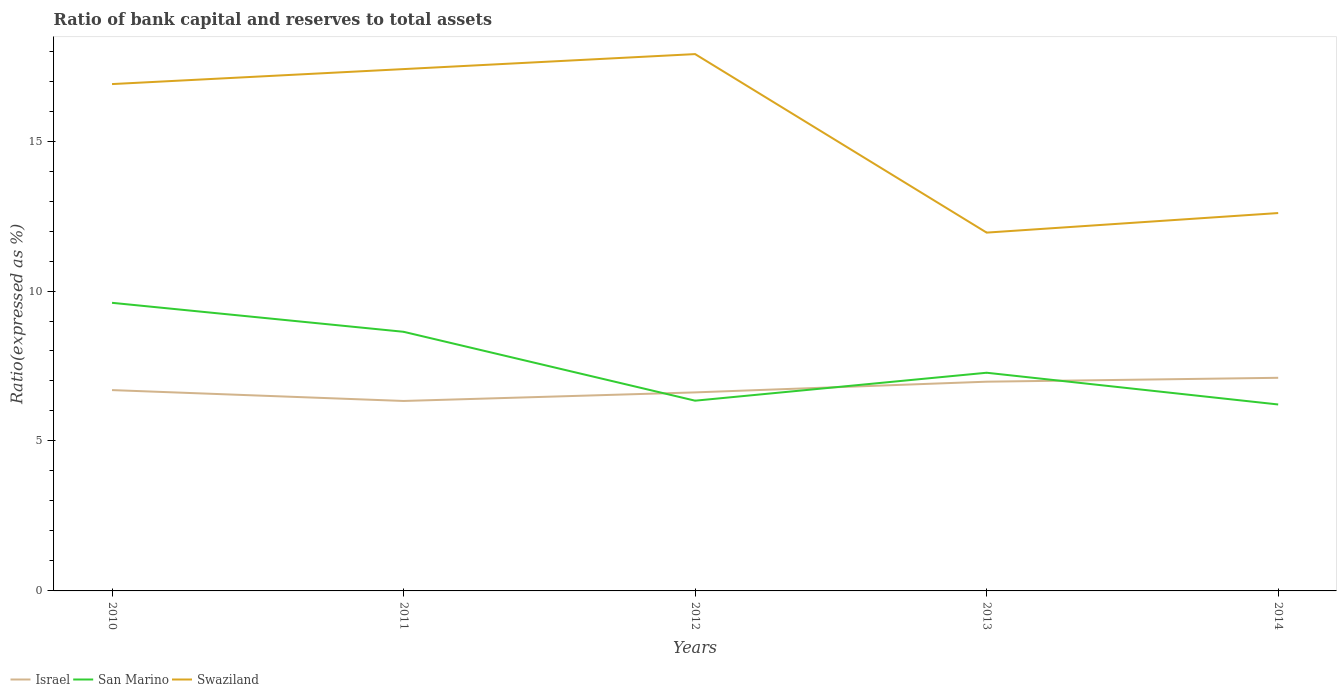How many different coloured lines are there?
Make the answer very short. 3. Does the line corresponding to Israel intersect with the line corresponding to San Marino?
Your answer should be very brief. Yes. Is the number of lines equal to the number of legend labels?
Offer a terse response. Yes. Across all years, what is the maximum ratio of bank capital and reserves to total assets in San Marino?
Make the answer very short. 6.22. In which year was the ratio of bank capital and reserves to total assets in Swaziland maximum?
Your answer should be compact. 2013. What is the total ratio of bank capital and reserves to total assets in San Marino in the graph?
Offer a very short reply. 0.13. What is the difference between the highest and the second highest ratio of bank capital and reserves to total assets in Israel?
Give a very brief answer. 0.77. How many lines are there?
Give a very brief answer. 3. How many years are there in the graph?
Your response must be concise. 5. What is the difference between two consecutive major ticks on the Y-axis?
Ensure brevity in your answer.  5. Does the graph contain any zero values?
Offer a terse response. No. How are the legend labels stacked?
Offer a terse response. Horizontal. What is the title of the graph?
Keep it short and to the point. Ratio of bank capital and reserves to total assets. Does "Channel Islands" appear as one of the legend labels in the graph?
Provide a short and direct response. No. What is the label or title of the X-axis?
Make the answer very short. Years. What is the label or title of the Y-axis?
Your answer should be compact. Ratio(expressed as %). What is the Ratio(expressed as %) in Israel in 2010?
Provide a succinct answer. 6.7. What is the Ratio(expressed as %) of San Marino in 2010?
Offer a very short reply. 9.61. What is the Ratio(expressed as %) of Israel in 2011?
Make the answer very short. 6.33. What is the Ratio(expressed as %) in San Marino in 2011?
Your answer should be very brief. 8.64. What is the Ratio(expressed as %) in Israel in 2012?
Give a very brief answer. 6.62. What is the Ratio(expressed as %) of San Marino in 2012?
Offer a very short reply. 6.34. What is the Ratio(expressed as %) in Swaziland in 2012?
Provide a succinct answer. 17.9. What is the Ratio(expressed as %) in Israel in 2013?
Provide a short and direct response. 6.98. What is the Ratio(expressed as %) in San Marino in 2013?
Give a very brief answer. 7.28. What is the Ratio(expressed as %) in Swaziland in 2013?
Ensure brevity in your answer.  11.95. What is the Ratio(expressed as %) in Israel in 2014?
Ensure brevity in your answer.  7.11. What is the Ratio(expressed as %) of San Marino in 2014?
Ensure brevity in your answer.  6.22. Across all years, what is the maximum Ratio(expressed as %) of Israel?
Your answer should be compact. 7.11. Across all years, what is the maximum Ratio(expressed as %) of San Marino?
Keep it short and to the point. 9.61. Across all years, what is the minimum Ratio(expressed as %) in Israel?
Ensure brevity in your answer.  6.33. Across all years, what is the minimum Ratio(expressed as %) in San Marino?
Your response must be concise. 6.22. Across all years, what is the minimum Ratio(expressed as %) of Swaziland?
Provide a short and direct response. 11.95. What is the total Ratio(expressed as %) of Israel in the graph?
Offer a terse response. 33.73. What is the total Ratio(expressed as %) of San Marino in the graph?
Give a very brief answer. 38.08. What is the total Ratio(expressed as %) in Swaziland in the graph?
Provide a succinct answer. 76.75. What is the difference between the Ratio(expressed as %) in Israel in 2010 and that in 2011?
Give a very brief answer. 0.36. What is the difference between the Ratio(expressed as %) of San Marino in 2010 and that in 2011?
Offer a terse response. 0.97. What is the difference between the Ratio(expressed as %) of Swaziland in 2010 and that in 2011?
Make the answer very short. -0.5. What is the difference between the Ratio(expressed as %) in Israel in 2010 and that in 2012?
Give a very brief answer. 0.08. What is the difference between the Ratio(expressed as %) of San Marino in 2010 and that in 2012?
Your response must be concise. 3.26. What is the difference between the Ratio(expressed as %) of Israel in 2010 and that in 2013?
Give a very brief answer. -0.28. What is the difference between the Ratio(expressed as %) in San Marino in 2010 and that in 2013?
Make the answer very short. 2.33. What is the difference between the Ratio(expressed as %) in Swaziland in 2010 and that in 2013?
Provide a succinct answer. 4.95. What is the difference between the Ratio(expressed as %) of Israel in 2010 and that in 2014?
Offer a very short reply. -0.41. What is the difference between the Ratio(expressed as %) of San Marino in 2010 and that in 2014?
Ensure brevity in your answer.  3.39. What is the difference between the Ratio(expressed as %) of Israel in 2011 and that in 2012?
Your answer should be compact. -0.29. What is the difference between the Ratio(expressed as %) of San Marino in 2011 and that in 2012?
Provide a short and direct response. 2.3. What is the difference between the Ratio(expressed as %) in Israel in 2011 and that in 2013?
Your answer should be very brief. -0.64. What is the difference between the Ratio(expressed as %) in San Marino in 2011 and that in 2013?
Your answer should be compact. 1.37. What is the difference between the Ratio(expressed as %) in Swaziland in 2011 and that in 2013?
Offer a very short reply. 5.45. What is the difference between the Ratio(expressed as %) of Israel in 2011 and that in 2014?
Make the answer very short. -0.77. What is the difference between the Ratio(expressed as %) of San Marino in 2011 and that in 2014?
Offer a terse response. 2.42. What is the difference between the Ratio(expressed as %) in Israel in 2012 and that in 2013?
Provide a succinct answer. -0.36. What is the difference between the Ratio(expressed as %) of San Marino in 2012 and that in 2013?
Give a very brief answer. -0.93. What is the difference between the Ratio(expressed as %) of Swaziland in 2012 and that in 2013?
Give a very brief answer. 5.95. What is the difference between the Ratio(expressed as %) in Israel in 2012 and that in 2014?
Provide a short and direct response. -0.49. What is the difference between the Ratio(expressed as %) of San Marino in 2012 and that in 2014?
Give a very brief answer. 0.13. What is the difference between the Ratio(expressed as %) of Swaziland in 2012 and that in 2014?
Your response must be concise. 5.3. What is the difference between the Ratio(expressed as %) of Israel in 2013 and that in 2014?
Your response must be concise. -0.13. What is the difference between the Ratio(expressed as %) of San Marino in 2013 and that in 2014?
Your response must be concise. 1.06. What is the difference between the Ratio(expressed as %) in Swaziland in 2013 and that in 2014?
Give a very brief answer. -0.65. What is the difference between the Ratio(expressed as %) of Israel in 2010 and the Ratio(expressed as %) of San Marino in 2011?
Offer a very short reply. -1.94. What is the difference between the Ratio(expressed as %) of Israel in 2010 and the Ratio(expressed as %) of Swaziland in 2011?
Offer a terse response. -10.7. What is the difference between the Ratio(expressed as %) in San Marino in 2010 and the Ratio(expressed as %) in Swaziland in 2011?
Keep it short and to the point. -7.79. What is the difference between the Ratio(expressed as %) of Israel in 2010 and the Ratio(expressed as %) of San Marino in 2012?
Offer a terse response. 0.35. What is the difference between the Ratio(expressed as %) of Israel in 2010 and the Ratio(expressed as %) of Swaziland in 2012?
Offer a very short reply. -11.2. What is the difference between the Ratio(expressed as %) of San Marino in 2010 and the Ratio(expressed as %) of Swaziland in 2012?
Your response must be concise. -8.29. What is the difference between the Ratio(expressed as %) in Israel in 2010 and the Ratio(expressed as %) in San Marino in 2013?
Provide a succinct answer. -0.58. What is the difference between the Ratio(expressed as %) of Israel in 2010 and the Ratio(expressed as %) of Swaziland in 2013?
Make the answer very short. -5.25. What is the difference between the Ratio(expressed as %) in San Marino in 2010 and the Ratio(expressed as %) in Swaziland in 2013?
Give a very brief answer. -2.34. What is the difference between the Ratio(expressed as %) in Israel in 2010 and the Ratio(expressed as %) in San Marino in 2014?
Your answer should be very brief. 0.48. What is the difference between the Ratio(expressed as %) of Israel in 2010 and the Ratio(expressed as %) of Swaziland in 2014?
Provide a succinct answer. -5.9. What is the difference between the Ratio(expressed as %) in San Marino in 2010 and the Ratio(expressed as %) in Swaziland in 2014?
Your answer should be very brief. -2.99. What is the difference between the Ratio(expressed as %) of Israel in 2011 and the Ratio(expressed as %) of San Marino in 2012?
Your response must be concise. -0.01. What is the difference between the Ratio(expressed as %) in Israel in 2011 and the Ratio(expressed as %) in Swaziland in 2012?
Offer a terse response. -11.57. What is the difference between the Ratio(expressed as %) of San Marino in 2011 and the Ratio(expressed as %) of Swaziland in 2012?
Give a very brief answer. -9.26. What is the difference between the Ratio(expressed as %) in Israel in 2011 and the Ratio(expressed as %) in San Marino in 2013?
Ensure brevity in your answer.  -0.94. What is the difference between the Ratio(expressed as %) in Israel in 2011 and the Ratio(expressed as %) in Swaziland in 2013?
Your answer should be compact. -5.61. What is the difference between the Ratio(expressed as %) of San Marino in 2011 and the Ratio(expressed as %) of Swaziland in 2013?
Your answer should be compact. -3.31. What is the difference between the Ratio(expressed as %) in Israel in 2011 and the Ratio(expressed as %) in San Marino in 2014?
Your answer should be very brief. 0.12. What is the difference between the Ratio(expressed as %) of Israel in 2011 and the Ratio(expressed as %) of Swaziland in 2014?
Keep it short and to the point. -6.27. What is the difference between the Ratio(expressed as %) of San Marino in 2011 and the Ratio(expressed as %) of Swaziland in 2014?
Your answer should be very brief. -3.96. What is the difference between the Ratio(expressed as %) of Israel in 2012 and the Ratio(expressed as %) of San Marino in 2013?
Your answer should be compact. -0.66. What is the difference between the Ratio(expressed as %) in Israel in 2012 and the Ratio(expressed as %) in Swaziland in 2013?
Make the answer very short. -5.33. What is the difference between the Ratio(expressed as %) of San Marino in 2012 and the Ratio(expressed as %) of Swaziland in 2013?
Offer a very short reply. -5.6. What is the difference between the Ratio(expressed as %) of Israel in 2012 and the Ratio(expressed as %) of San Marino in 2014?
Offer a very short reply. 0.4. What is the difference between the Ratio(expressed as %) in Israel in 2012 and the Ratio(expressed as %) in Swaziland in 2014?
Your response must be concise. -5.98. What is the difference between the Ratio(expressed as %) in San Marino in 2012 and the Ratio(expressed as %) in Swaziland in 2014?
Provide a succinct answer. -6.26. What is the difference between the Ratio(expressed as %) in Israel in 2013 and the Ratio(expressed as %) in San Marino in 2014?
Offer a terse response. 0.76. What is the difference between the Ratio(expressed as %) in Israel in 2013 and the Ratio(expressed as %) in Swaziland in 2014?
Offer a terse response. -5.62. What is the difference between the Ratio(expressed as %) of San Marino in 2013 and the Ratio(expressed as %) of Swaziland in 2014?
Offer a very short reply. -5.32. What is the average Ratio(expressed as %) in Israel per year?
Give a very brief answer. 6.75. What is the average Ratio(expressed as %) of San Marino per year?
Give a very brief answer. 7.62. What is the average Ratio(expressed as %) in Swaziland per year?
Make the answer very short. 15.35. In the year 2010, what is the difference between the Ratio(expressed as %) in Israel and Ratio(expressed as %) in San Marino?
Ensure brevity in your answer.  -2.91. In the year 2010, what is the difference between the Ratio(expressed as %) in Israel and Ratio(expressed as %) in Swaziland?
Ensure brevity in your answer.  -10.2. In the year 2010, what is the difference between the Ratio(expressed as %) of San Marino and Ratio(expressed as %) of Swaziland?
Offer a terse response. -7.29. In the year 2011, what is the difference between the Ratio(expressed as %) in Israel and Ratio(expressed as %) in San Marino?
Give a very brief answer. -2.31. In the year 2011, what is the difference between the Ratio(expressed as %) of Israel and Ratio(expressed as %) of Swaziland?
Your answer should be very brief. -11.07. In the year 2011, what is the difference between the Ratio(expressed as %) of San Marino and Ratio(expressed as %) of Swaziland?
Offer a terse response. -8.76. In the year 2012, what is the difference between the Ratio(expressed as %) of Israel and Ratio(expressed as %) of San Marino?
Give a very brief answer. 0.28. In the year 2012, what is the difference between the Ratio(expressed as %) in Israel and Ratio(expressed as %) in Swaziland?
Your answer should be compact. -11.28. In the year 2012, what is the difference between the Ratio(expressed as %) in San Marino and Ratio(expressed as %) in Swaziland?
Offer a terse response. -11.56. In the year 2013, what is the difference between the Ratio(expressed as %) of Israel and Ratio(expressed as %) of San Marino?
Offer a very short reply. -0.3. In the year 2013, what is the difference between the Ratio(expressed as %) of Israel and Ratio(expressed as %) of Swaziland?
Your answer should be compact. -4.97. In the year 2013, what is the difference between the Ratio(expressed as %) in San Marino and Ratio(expressed as %) in Swaziland?
Your answer should be compact. -4.67. In the year 2014, what is the difference between the Ratio(expressed as %) in Israel and Ratio(expressed as %) in San Marino?
Your response must be concise. 0.89. In the year 2014, what is the difference between the Ratio(expressed as %) of Israel and Ratio(expressed as %) of Swaziland?
Provide a succinct answer. -5.49. In the year 2014, what is the difference between the Ratio(expressed as %) in San Marino and Ratio(expressed as %) in Swaziland?
Your answer should be compact. -6.38. What is the ratio of the Ratio(expressed as %) in Israel in 2010 to that in 2011?
Your response must be concise. 1.06. What is the ratio of the Ratio(expressed as %) in San Marino in 2010 to that in 2011?
Make the answer very short. 1.11. What is the ratio of the Ratio(expressed as %) of Swaziland in 2010 to that in 2011?
Provide a short and direct response. 0.97. What is the ratio of the Ratio(expressed as %) in Israel in 2010 to that in 2012?
Offer a terse response. 1.01. What is the ratio of the Ratio(expressed as %) in San Marino in 2010 to that in 2012?
Make the answer very short. 1.51. What is the ratio of the Ratio(expressed as %) in Swaziland in 2010 to that in 2012?
Your answer should be compact. 0.94. What is the ratio of the Ratio(expressed as %) of Israel in 2010 to that in 2013?
Provide a succinct answer. 0.96. What is the ratio of the Ratio(expressed as %) of San Marino in 2010 to that in 2013?
Keep it short and to the point. 1.32. What is the ratio of the Ratio(expressed as %) in Swaziland in 2010 to that in 2013?
Ensure brevity in your answer.  1.41. What is the ratio of the Ratio(expressed as %) in Israel in 2010 to that in 2014?
Ensure brevity in your answer.  0.94. What is the ratio of the Ratio(expressed as %) in San Marino in 2010 to that in 2014?
Provide a short and direct response. 1.55. What is the ratio of the Ratio(expressed as %) of Swaziland in 2010 to that in 2014?
Ensure brevity in your answer.  1.34. What is the ratio of the Ratio(expressed as %) in Israel in 2011 to that in 2012?
Your response must be concise. 0.96. What is the ratio of the Ratio(expressed as %) of San Marino in 2011 to that in 2012?
Your response must be concise. 1.36. What is the ratio of the Ratio(expressed as %) of Swaziland in 2011 to that in 2012?
Provide a short and direct response. 0.97. What is the ratio of the Ratio(expressed as %) of Israel in 2011 to that in 2013?
Provide a succinct answer. 0.91. What is the ratio of the Ratio(expressed as %) of San Marino in 2011 to that in 2013?
Your answer should be very brief. 1.19. What is the ratio of the Ratio(expressed as %) of Swaziland in 2011 to that in 2013?
Your answer should be compact. 1.46. What is the ratio of the Ratio(expressed as %) in Israel in 2011 to that in 2014?
Make the answer very short. 0.89. What is the ratio of the Ratio(expressed as %) in San Marino in 2011 to that in 2014?
Ensure brevity in your answer.  1.39. What is the ratio of the Ratio(expressed as %) of Swaziland in 2011 to that in 2014?
Give a very brief answer. 1.38. What is the ratio of the Ratio(expressed as %) of Israel in 2012 to that in 2013?
Ensure brevity in your answer.  0.95. What is the ratio of the Ratio(expressed as %) of San Marino in 2012 to that in 2013?
Provide a succinct answer. 0.87. What is the ratio of the Ratio(expressed as %) of Swaziland in 2012 to that in 2013?
Give a very brief answer. 1.5. What is the ratio of the Ratio(expressed as %) of Israel in 2012 to that in 2014?
Make the answer very short. 0.93. What is the ratio of the Ratio(expressed as %) of San Marino in 2012 to that in 2014?
Provide a succinct answer. 1.02. What is the ratio of the Ratio(expressed as %) of Swaziland in 2012 to that in 2014?
Ensure brevity in your answer.  1.42. What is the ratio of the Ratio(expressed as %) of Israel in 2013 to that in 2014?
Your answer should be compact. 0.98. What is the ratio of the Ratio(expressed as %) in San Marino in 2013 to that in 2014?
Provide a succinct answer. 1.17. What is the ratio of the Ratio(expressed as %) in Swaziland in 2013 to that in 2014?
Provide a succinct answer. 0.95. What is the difference between the highest and the second highest Ratio(expressed as %) of Israel?
Offer a very short reply. 0.13. What is the difference between the highest and the second highest Ratio(expressed as %) in San Marino?
Your answer should be very brief. 0.97. What is the difference between the highest and the lowest Ratio(expressed as %) of Israel?
Offer a terse response. 0.77. What is the difference between the highest and the lowest Ratio(expressed as %) of San Marino?
Offer a terse response. 3.39. What is the difference between the highest and the lowest Ratio(expressed as %) of Swaziland?
Make the answer very short. 5.95. 